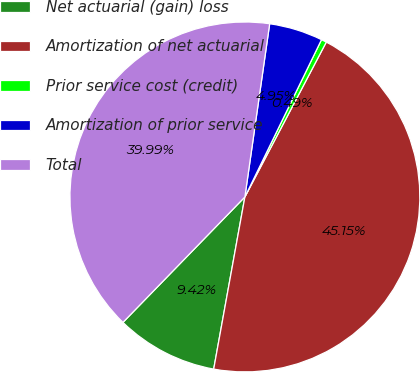Convert chart to OTSL. <chart><loc_0><loc_0><loc_500><loc_500><pie_chart><fcel>Net actuarial (gain) loss<fcel>Amortization of net actuarial<fcel>Prior service cost (credit)<fcel>Amortization of prior service<fcel>Total<nl><fcel>9.42%<fcel>45.15%<fcel>0.49%<fcel>4.95%<fcel>39.99%<nl></chart> 